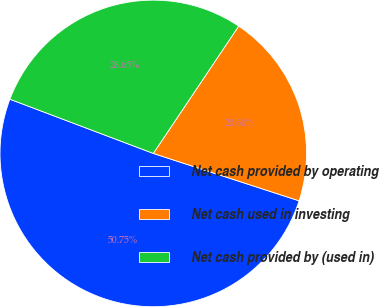Convert chart to OTSL. <chart><loc_0><loc_0><loc_500><loc_500><pie_chart><fcel>Net cash provided by operating<fcel>Net cash used in investing<fcel>Net cash provided by (used in)<nl><fcel>50.75%<fcel>20.6%<fcel>28.65%<nl></chart> 